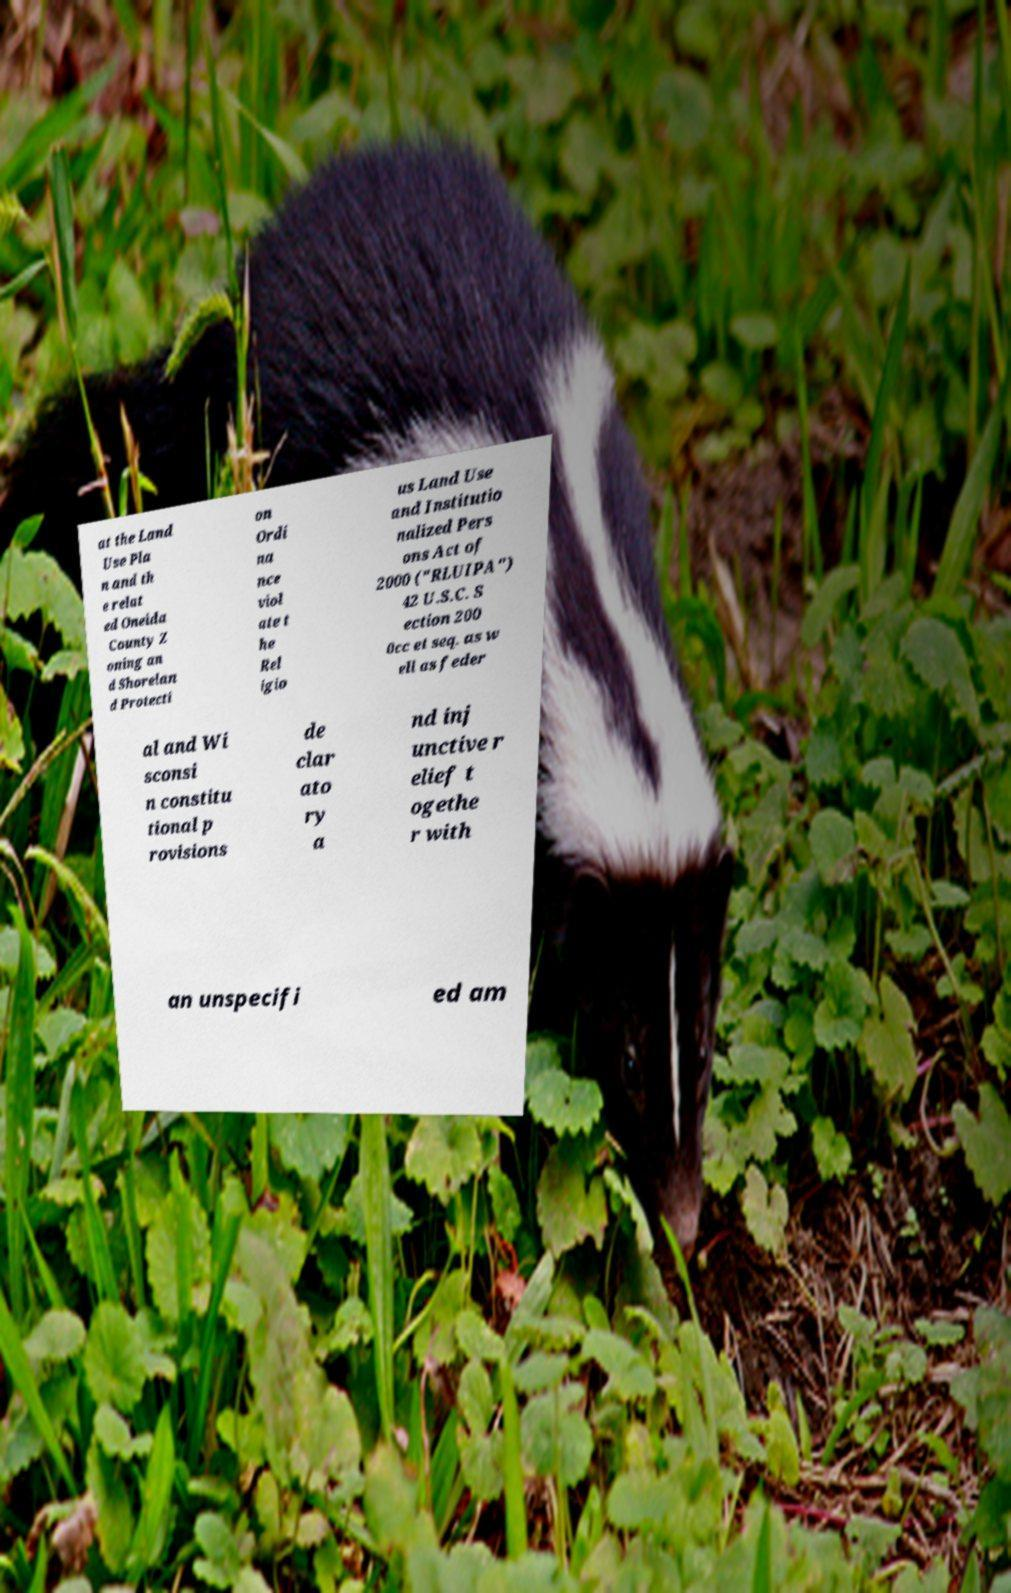Please identify and transcribe the text found in this image. at the Land Use Pla n and th e relat ed Oneida County Z oning an d Shorelan d Protecti on Ordi na nce viol ate t he Rel igio us Land Use and Institutio nalized Pers ons Act of 2000 ("RLUIPA") 42 U.S.C. S ection 200 0cc et seq. as w ell as feder al and Wi sconsi n constitu tional p rovisions de clar ato ry a nd inj unctive r elief t ogethe r with an unspecifi ed am 